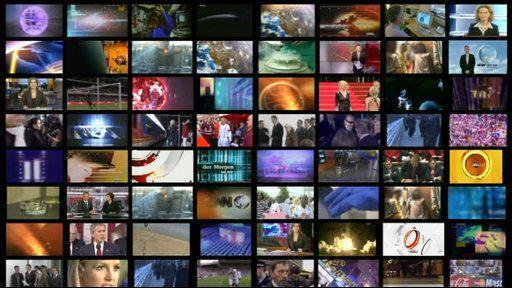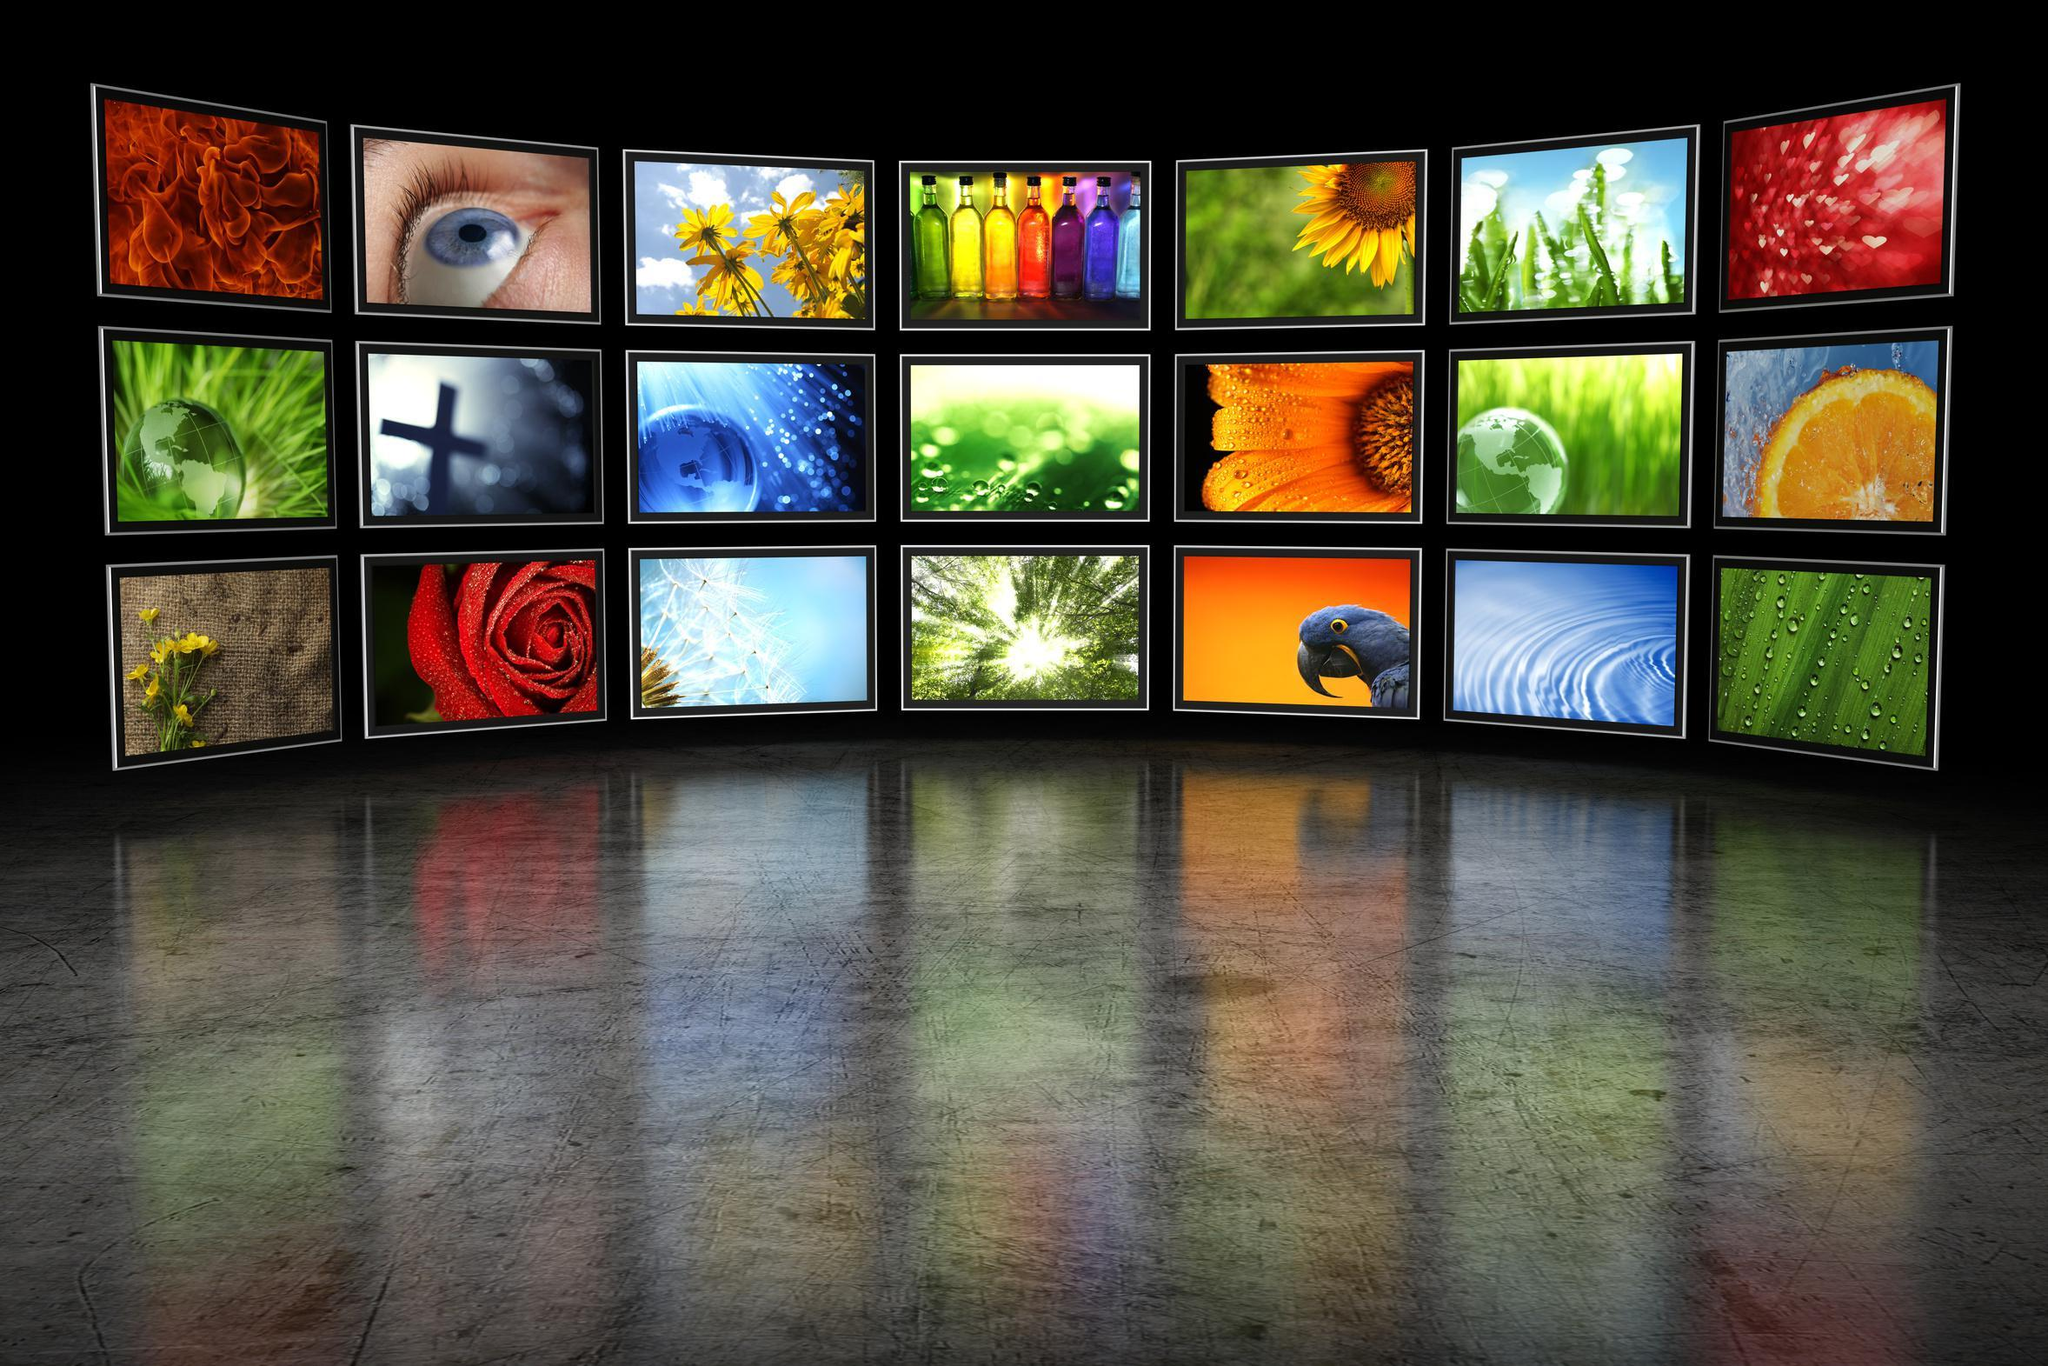The first image is the image on the left, the second image is the image on the right. For the images shown, is this caption "People are hanging around in a barlike atmosphere in one of the images." true? Answer yes or no. No. The first image is the image on the left, the second image is the image on the right. Examine the images to the left and right. Is the description "Left image shows people in a bar with a row of screens overhead." accurate? Answer yes or no. No. 